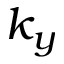<formula> <loc_0><loc_0><loc_500><loc_500>k _ { y }</formula> 